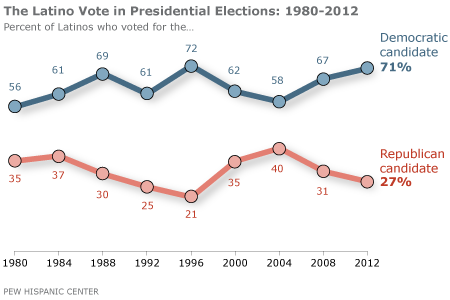Indicate a few pertinent items in this graphic. What is the value of the leftmost blue data point? Of the blue data points with values above 60, seven have been identified. 